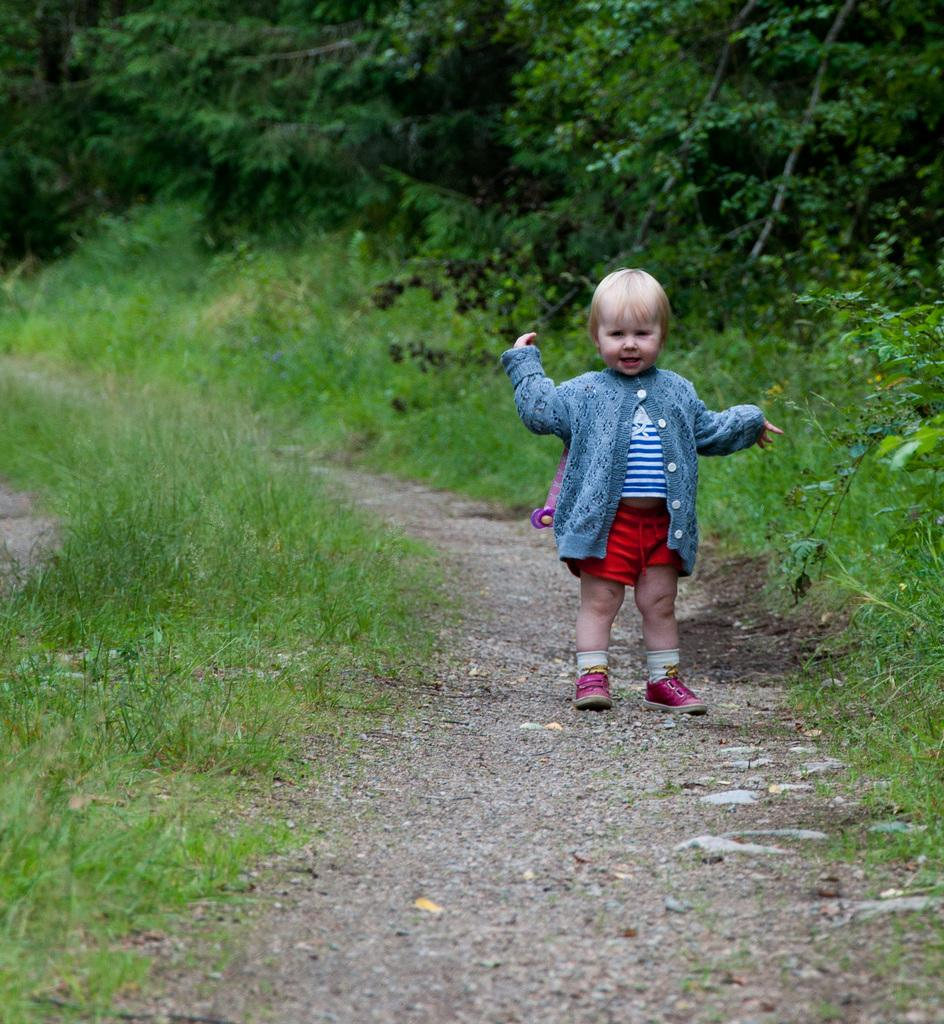What is the main subject of the image? There is a child standing in the image. Where is the child standing? The child is standing on the ground. What type of natural environment is visible in the image? There are trees, plants, and grass in the image. What type of legal advice is the child providing in the image? There is no indication in the image that the child is providing legal advice or acting as a lawyer. 